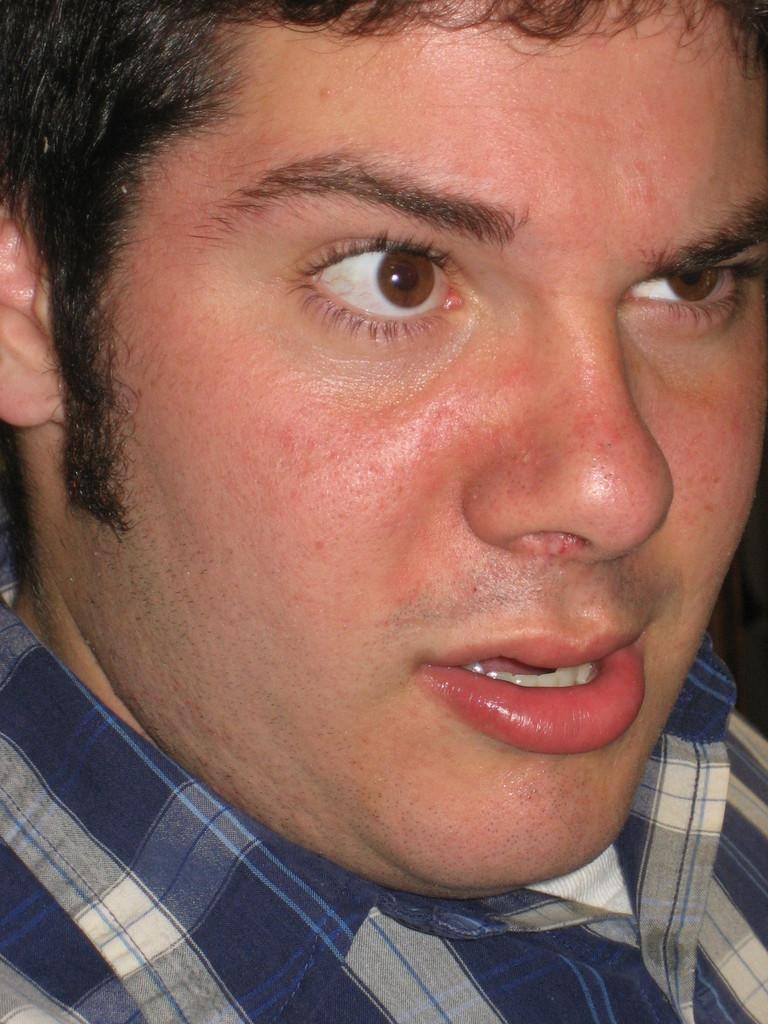What is the main subject of the image? The main subject of the image is a man. Can you describe the man's clothing in the image? The man is wearing a blue and white color checked shirt in the image. What type of boats can be seen in the garden behind the man in the image? There are no boats or gardens present in the image; it only features a man wearing a blue and white color checked shirt. 